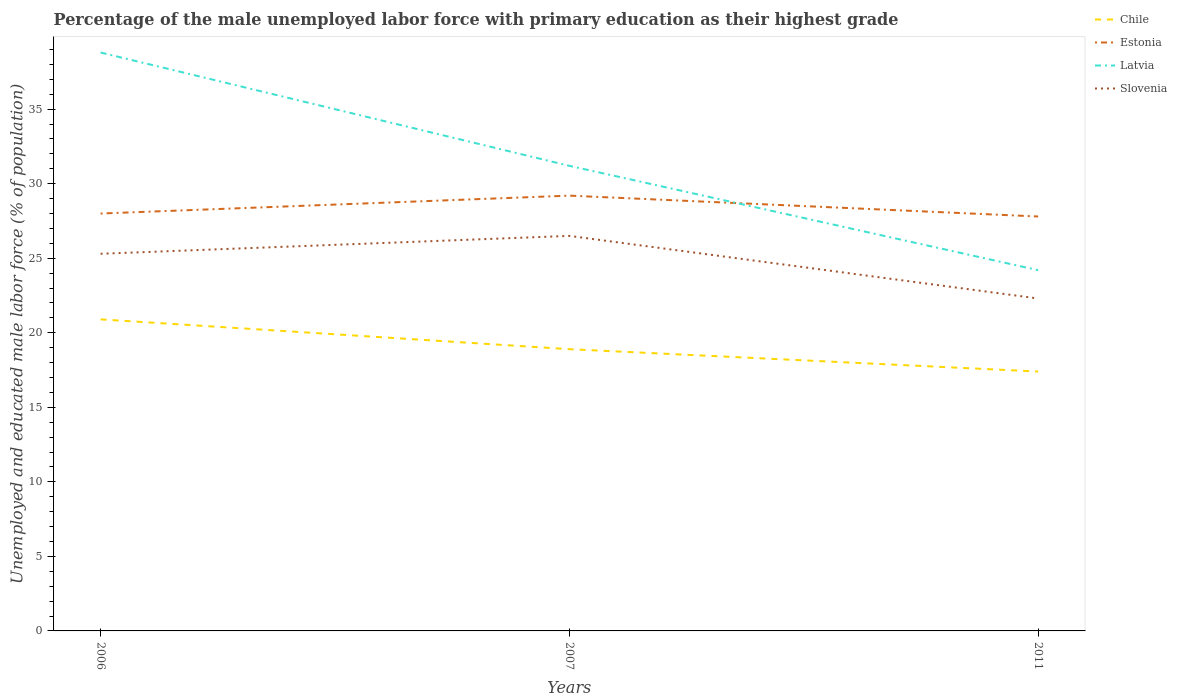How many different coloured lines are there?
Your response must be concise. 4. Is the number of lines equal to the number of legend labels?
Provide a succinct answer. Yes. Across all years, what is the maximum percentage of the unemployed male labor force with primary education in Latvia?
Your answer should be compact. 24.2. In which year was the percentage of the unemployed male labor force with primary education in Slovenia maximum?
Keep it short and to the point. 2011. What is the total percentage of the unemployed male labor force with primary education in Slovenia in the graph?
Provide a succinct answer. 4.2. What is the difference between the highest and the second highest percentage of the unemployed male labor force with primary education in Latvia?
Keep it short and to the point. 14.6. Is the percentage of the unemployed male labor force with primary education in Latvia strictly greater than the percentage of the unemployed male labor force with primary education in Slovenia over the years?
Your answer should be compact. No. How many lines are there?
Keep it short and to the point. 4. What is the difference between two consecutive major ticks on the Y-axis?
Give a very brief answer. 5. Are the values on the major ticks of Y-axis written in scientific E-notation?
Provide a short and direct response. No. Does the graph contain any zero values?
Make the answer very short. No. How many legend labels are there?
Ensure brevity in your answer.  4. How are the legend labels stacked?
Ensure brevity in your answer.  Vertical. What is the title of the graph?
Make the answer very short. Percentage of the male unemployed labor force with primary education as their highest grade. Does "Togo" appear as one of the legend labels in the graph?
Your answer should be compact. No. What is the label or title of the X-axis?
Your response must be concise. Years. What is the label or title of the Y-axis?
Keep it short and to the point. Unemployed and educated male labor force (% of population). What is the Unemployed and educated male labor force (% of population) in Chile in 2006?
Make the answer very short. 20.9. What is the Unemployed and educated male labor force (% of population) in Estonia in 2006?
Your response must be concise. 28. What is the Unemployed and educated male labor force (% of population) in Latvia in 2006?
Give a very brief answer. 38.8. What is the Unemployed and educated male labor force (% of population) of Slovenia in 2006?
Your answer should be very brief. 25.3. What is the Unemployed and educated male labor force (% of population) in Chile in 2007?
Offer a very short reply. 18.9. What is the Unemployed and educated male labor force (% of population) in Estonia in 2007?
Ensure brevity in your answer.  29.2. What is the Unemployed and educated male labor force (% of population) of Latvia in 2007?
Keep it short and to the point. 31.2. What is the Unemployed and educated male labor force (% of population) in Slovenia in 2007?
Your response must be concise. 26.5. What is the Unemployed and educated male labor force (% of population) in Chile in 2011?
Ensure brevity in your answer.  17.4. What is the Unemployed and educated male labor force (% of population) of Estonia in 2011?
Ensure brevity in your answer.  27.8. What is the Unemployed and educated male labor force (% of population) in Latvia in 2011?
Offer a terse response. 24.2. What is the Unemployed and educated male labor force (% of population) in Slovenia in 2011?
Your response must be concise. 22.3. Across all years, what is the maximum Unemployed and educated male labor force (% of population) in Chile?
Your answer should be compact. 20.9. Across all years, what is the maximum Unemployed and educated male labor force (% of population) of Estonia?
Give a very brief answer. 29.2. Across all years, what is the maximum Unemployed and educated male labor force (% of population) of Latvia?
Your answer should be very brief. 38.8. Across all years, what is the minimum Unemployed and educated male labor force (% of population) in Chile?
Provide a succinct answer. 17.4. Across all years, what is the minimum Unemployed and educated male labor force (% of population) of Estonia?
Keep it short and to the point. 27.8. Across all years, what is the minimum Unemployed and educated male labor force (% of population) of Latvia?
Provide a short and direct response. 24.2. Across all years, what is the minimum Unemployed and educated male labor force (% of population) in Slovenia?
Offer a very short reply. 22.3. What is the total Unemployed and educated male labor force (% of population) in Chile in the graph?
Your answer should be compact. 57.2. What is the total Unemployed and educated male labor force (% of population) in Estonia in the graph?
Your answer should be compact. 85. What is the total Unemployed and educated male labor force (% of population) in Latvia in the graph?
Offer a very short reply. 94.2. What is the total Unemployed and educated male labor force (% of population) of Slovenia in the graph?
Your response must be concise. 74.1. What is the difference between the Unemployed and educated male labor force (% of population) in Estonia in 2006 and that in 2007?
Keep it short and to the point. -1.2. What is the difference between the Unemployed and educated male labor force (% of population) of Latvia in 2006 and that in 2007?
Your answer should be compact. 7.6. What is the difference between the Unemployed and educated male labor force (% of population) in Slovenia in 2006 and that in 2007?
Keep it short and to the point. -1.2. What is the difference between the Unemployed and educated male labor force (% of population) of Estonia in 2006 and that in 2011?
Ensure brevity in your answer.  0.2. What is the difference between the Unemployed and educated male labor force (% of population) in Latvia in 2007 and that in 2011?
Your answer should be very brief. 7. What is the difference between the Unemployed and educated male labor force (% of population) of Estonia in 2006 and the Unemployed and educated male labor force (% of population) of Slovenia in 2007?
Your answer should be compact. 1.5. What is the difference between the Unemployed and educated male labor force (% of population) of Latvia in 2006 and the Unemployed and educated male labor force (% of population) of Slovenia in 2007?
Make the answer very short. 12.3. What is the difference between the Unemployed and educated male labor force (% of population) in Chile in 2006 and the Unemployed and educated male labor force (% of population) in Latvia in 2011?
Make the answer very short. -3.3. What is the difference between the Unemployed and educated male labor force (% of population) of Estonia in 2006 and the Unemployed and educated male labor force (% of population) of Latvia in 2011?
Your response must be concise. 3.8. What is the difference between the Unemployed and educated male labor force (% of population) in Latvia in 2006 and the Unemployed and educated male labor force (% of population) in Slovenia in 2011?
Provide a short and direct response. 16.5. What is the difference between the Unemployed and educated male labor force (% of population) in Chile in 2007 and the Unemployed and educated male labor force (% of population) in Estonia in 2011?
Your response must be concise. -8.9. What is the difference between the Unemployed and educated male labor force (% of population) of Chile in 2007 and the Unemployed and educated male labor force (% of population) of Latvia in 2011?
Your answer should be very brief. -5.3. What is the difference between the Unemployed and educated male labor force (% of population) in Estonia in 2007 and the Unemployed and educated male labor force (% of population) in Latvia in 2011?
Your answer should be very brief. 5. What is the difference between the Unemployed and educated male labor force (% of population) in Latvia in 2007 and the Unemployed and educated male labor force (% of population) in Slovenia in 2011?
Your answer should be very brief. 8.9. What is the average Unemployed and educated male labor force (% of population) of Chile per year?
Make the answer very short. 19.07. What is the average Unemployed and educated male labor force (% of population) in Estonia per year?
Keep it short and to the point. 28.33. What is the average Unemployed and educated male labor force (% of population) of Latvia per year?
Provide a succinct answer. 31.4. What is the average Unemployed and educated male labor force (% of population) in Slovenia per year?
Make the answer very short. 24.7. In the year 2006, what is the difference between the Unemployed and educated male labor force (% of population) in Chile and Unemployed and educated male labor force (% of population) in Latvia?
Make the answer very short. -17.9. In the year 2006, what is the difference between the Unemployed and educated male labor force (% of population) of Chile and Unemployed and educated male labor force (% of population) of Slovenia?
Give a very brief answer. -4.4. In the year 2006, what is the difference between the Unemployed and educated male labor force (% of population) in Estonia and Unemployed and educated male labor force (% of population) in Slovenia?
Ensure brevity in your answer.  2.7. In the year 2006, what is the difference between the Unemployed and educated male labor force (% of population) of Latvia and Unemployed and educated male labor force (% of population) of Slovenia?
Provide a succinct answer. 13.5. In the year 2007, what is the difference between the Unemployed and educated male labor force (% of population) of Chile and Unemployed and educated male labor force (% of population) of Latvia?
Offer a terse response. -12.3. In the year 2007, what is the difference between the Unemployed and educated male labor force (% of population) of Estonia and Unemployed and educated male labor force (% of population) of Latvia?
Ensure brevity in your answer.  -2. In the year 2011, what is the difference between the Unemployed and educated male labor force (% of population) in Chile and Unemployed and educated male labor force (% of population) in Estonia?
Make the answer very short. -10.4. In the year 2011, what is the difference between the Unemployed and educated male labor force (% of population) of Chile and Unemployed and educated male labor force (% of population) of Latvia?
Make the answer very short. -6.8. In the year 2011, what is the difference between the Unemployed and educated male labor force (% of population) of Estonia and Unemployed and educated male labor force (% of population) of Latvia?
Your response must be concise. 3.6. In the year 2011, what is the difference between the Unemployed and educated male labor force (% of population) in Estonia and Unemployed and educated male labor force (% of population) in Slovenia?
Your answer should be very brief. 5.5. What is the ratio of the Unemployed and educated male labor force (% of population) of Chile in 2006 to that in 2007?
Provide a short and direct response. 1.11. What is the ratio of the Unemployed and educated male labor force (% of population) in Estonia in 2006 to that in 2007?
Give a very brief answer. 0.96. What is the ratio of the Unemployed and educated male labor force (% of population) of Latvia in 2006 to that in 2007?
Offer a very short reply. 1.24. What is the ratio of the Unemployed and educated male labor force (% of population) in Slovenia in 2006 to that in 2007?
Ensure brevity in your answer.  0.95. What is the ratio of the Unemployed and educated male labor force (% of population) of Chile in 2006 to that in 2011?
Offer a very short reply. 1.2. What is the ratio of the Unemployed and educated male labor force (% of population) of Estonia in 2006 to that in 2011?
Ensure brevity in your answer.  1.01. What is the ratio of the Unemployed and educated male labor force (% of population) of Latvia in 2006 to that in 2011?
Your answer should be compact. 1.6. What is the ratio of the Unemployed and educated male labor force (% of population) in Slovenia in 2006 to that in 2011?
Make the answer very short. 1.13. What is the ratio of the Unemployed and educated male labor force (% of population) of Chile in 2007 to that in 2011?
Your response must be concise. 1.09. What is the ratio of the Unemployed and educated male labor force (% of population) of Estonia in 2007 to that in 2011?
Your answer should be very brief. 1.05. What is the ratio of the Unemployed and educated male labor force (% of population) in Latvia in 2007 to that in 2011?
Keep it short and to the point. 1.29. What is the ratio of the Unemployed and educated male labor force (% of population) in Slovenia in 2007 to that in 2011?
Your answer should be very brief. 1.19. What is the difference between the highest and the lowest Unemployed and educated male labor force (% of population) of Estonia?
Ensure brevity in your answer.  1.4. 